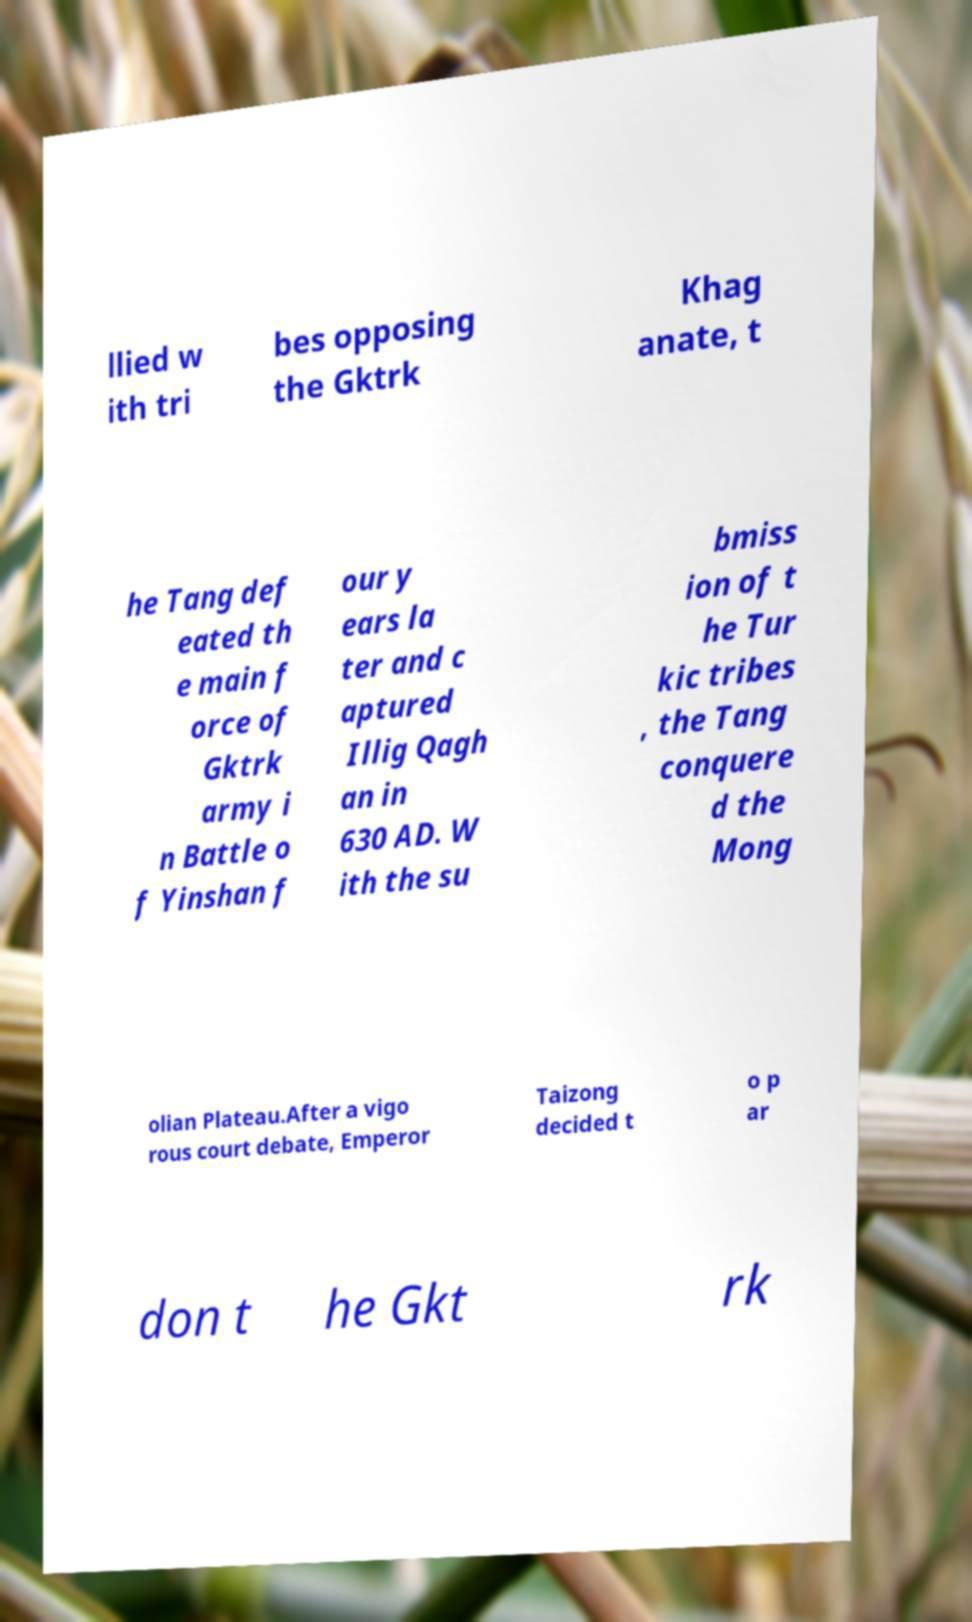Can you accurately transcribe the text from the provided image for me? llied w ith tri bes opposing the Gktrk Khag anate, t he Tang def eated th e main f orce of Gktrk army i n Battle o f Yinshan f our y ears la ter and c aptured Illig Qagh an in 630 AD. W ith the su bmiss ion of t he Tur kic tribes , the Tang conquere d the Mong olian Plateau.After a vigo rous court debate, Emperor Taizong decided t o p ar don t he Gkt rk 